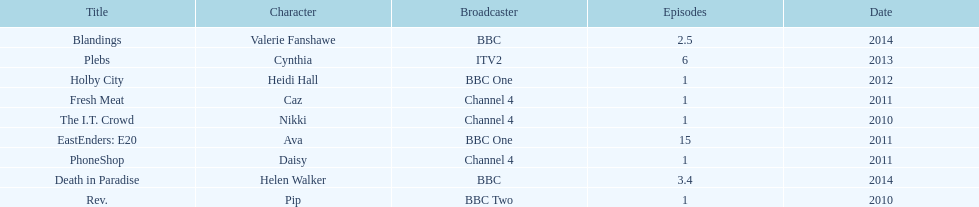Blandings and death in paradise both aired on which broadcaster? BBC. 